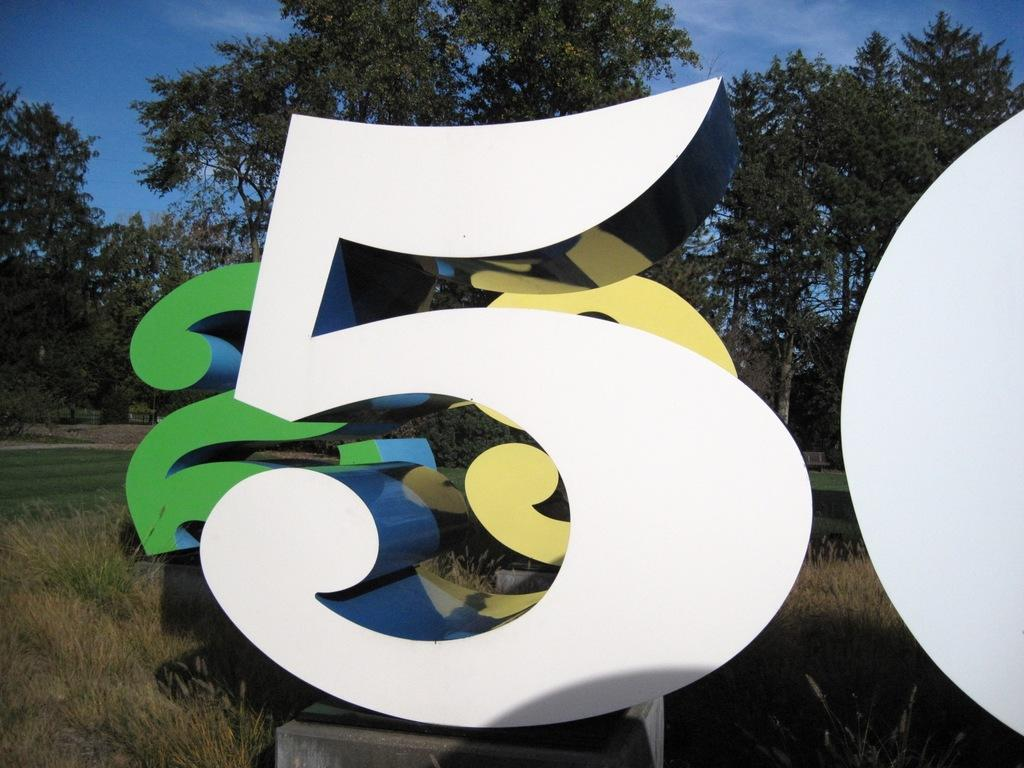What can be seen on the surface in the image? There are numbers on the surface in the image. What type of vegetation is visible in the image? There is grass visible in the image, and there are also plants. What part of the natural environment can be seen in the image? The sky is visible in the image. What type of underwear is hanging on the plants in the image? There is no underwear present in the image; it only features numbers, grass, plants, and the sky. 